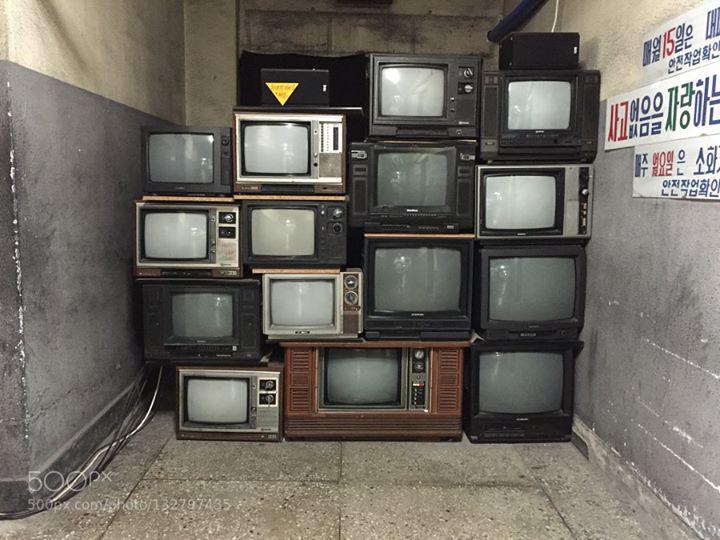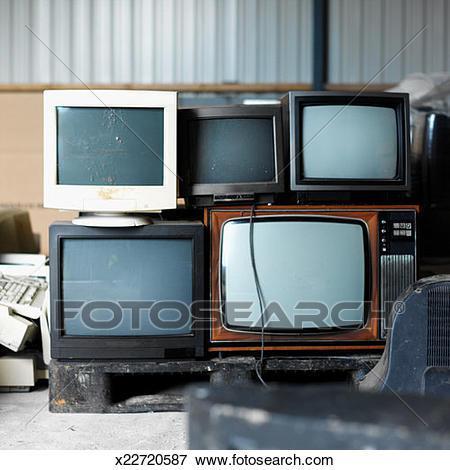The first image is the image on the left, the second image is the image on the right. For the images shown, is this caption "There are no more than 5 televisions in the right image." true? Answer yes or no. Yes. 